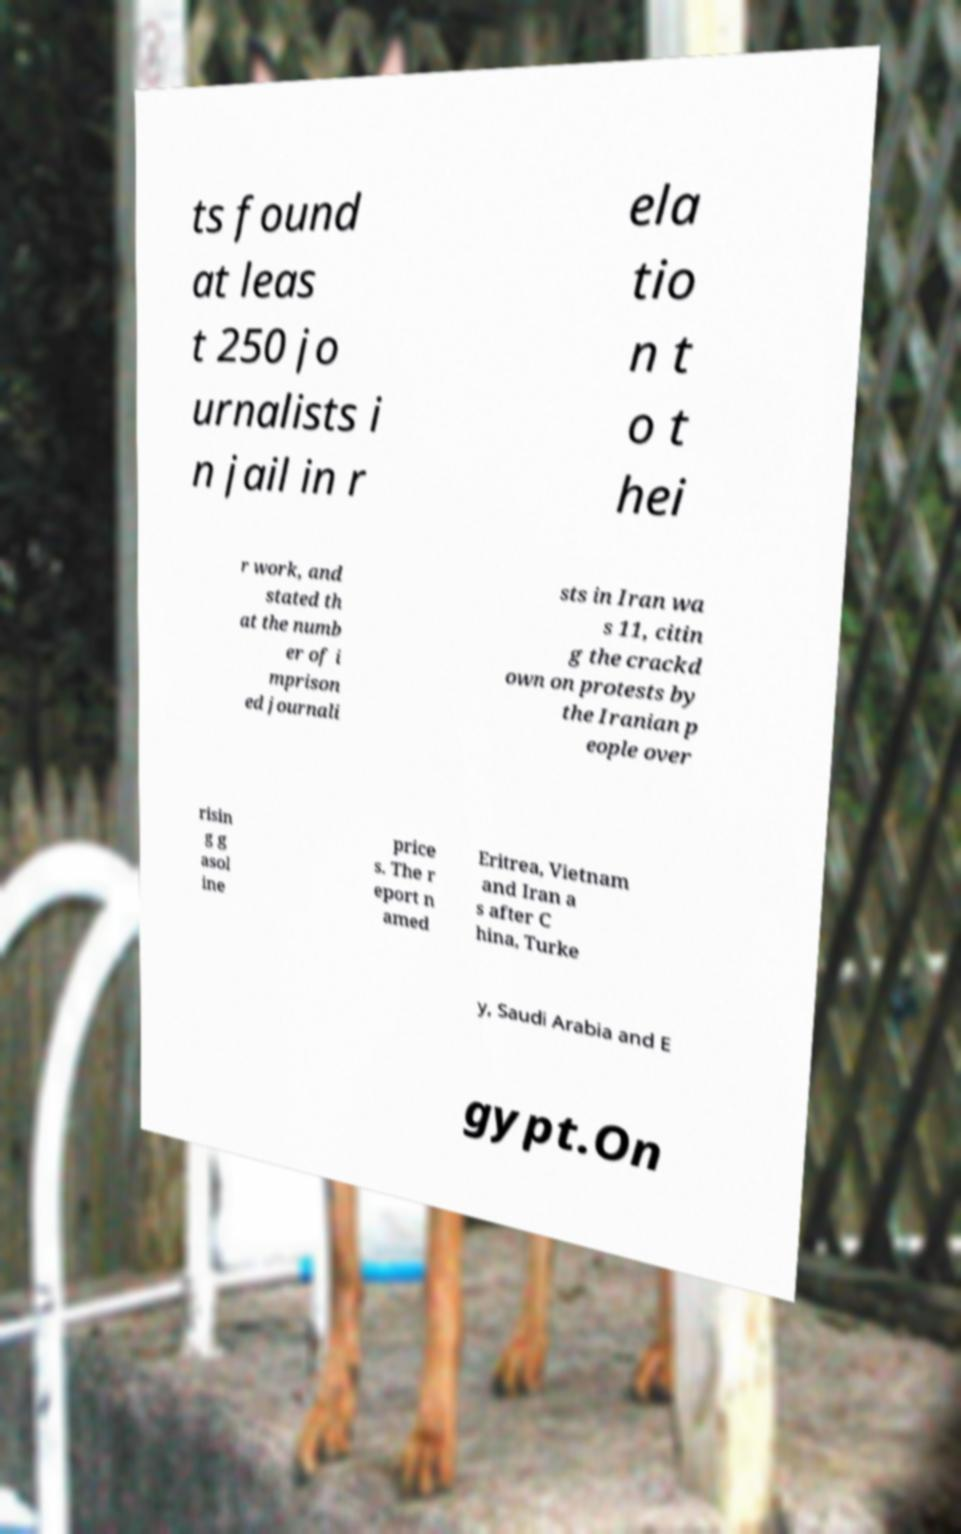For documentation purposes, I need the text within this image transcribed. Could you provide that? ts found at leas t 250 jo urnalists i n jail in r ela tio n t o t hei r work, and stated th at the numb er of i mprison ed journali sts in Iran wa s 11, citin g the crackd own on protests by the Iranian p eople over risin g g asol ine price s. The r eport n amed Eritrea, Vietnam and Iran a s after C hina, Turke y, Saudi Arabia and E gypt.On 